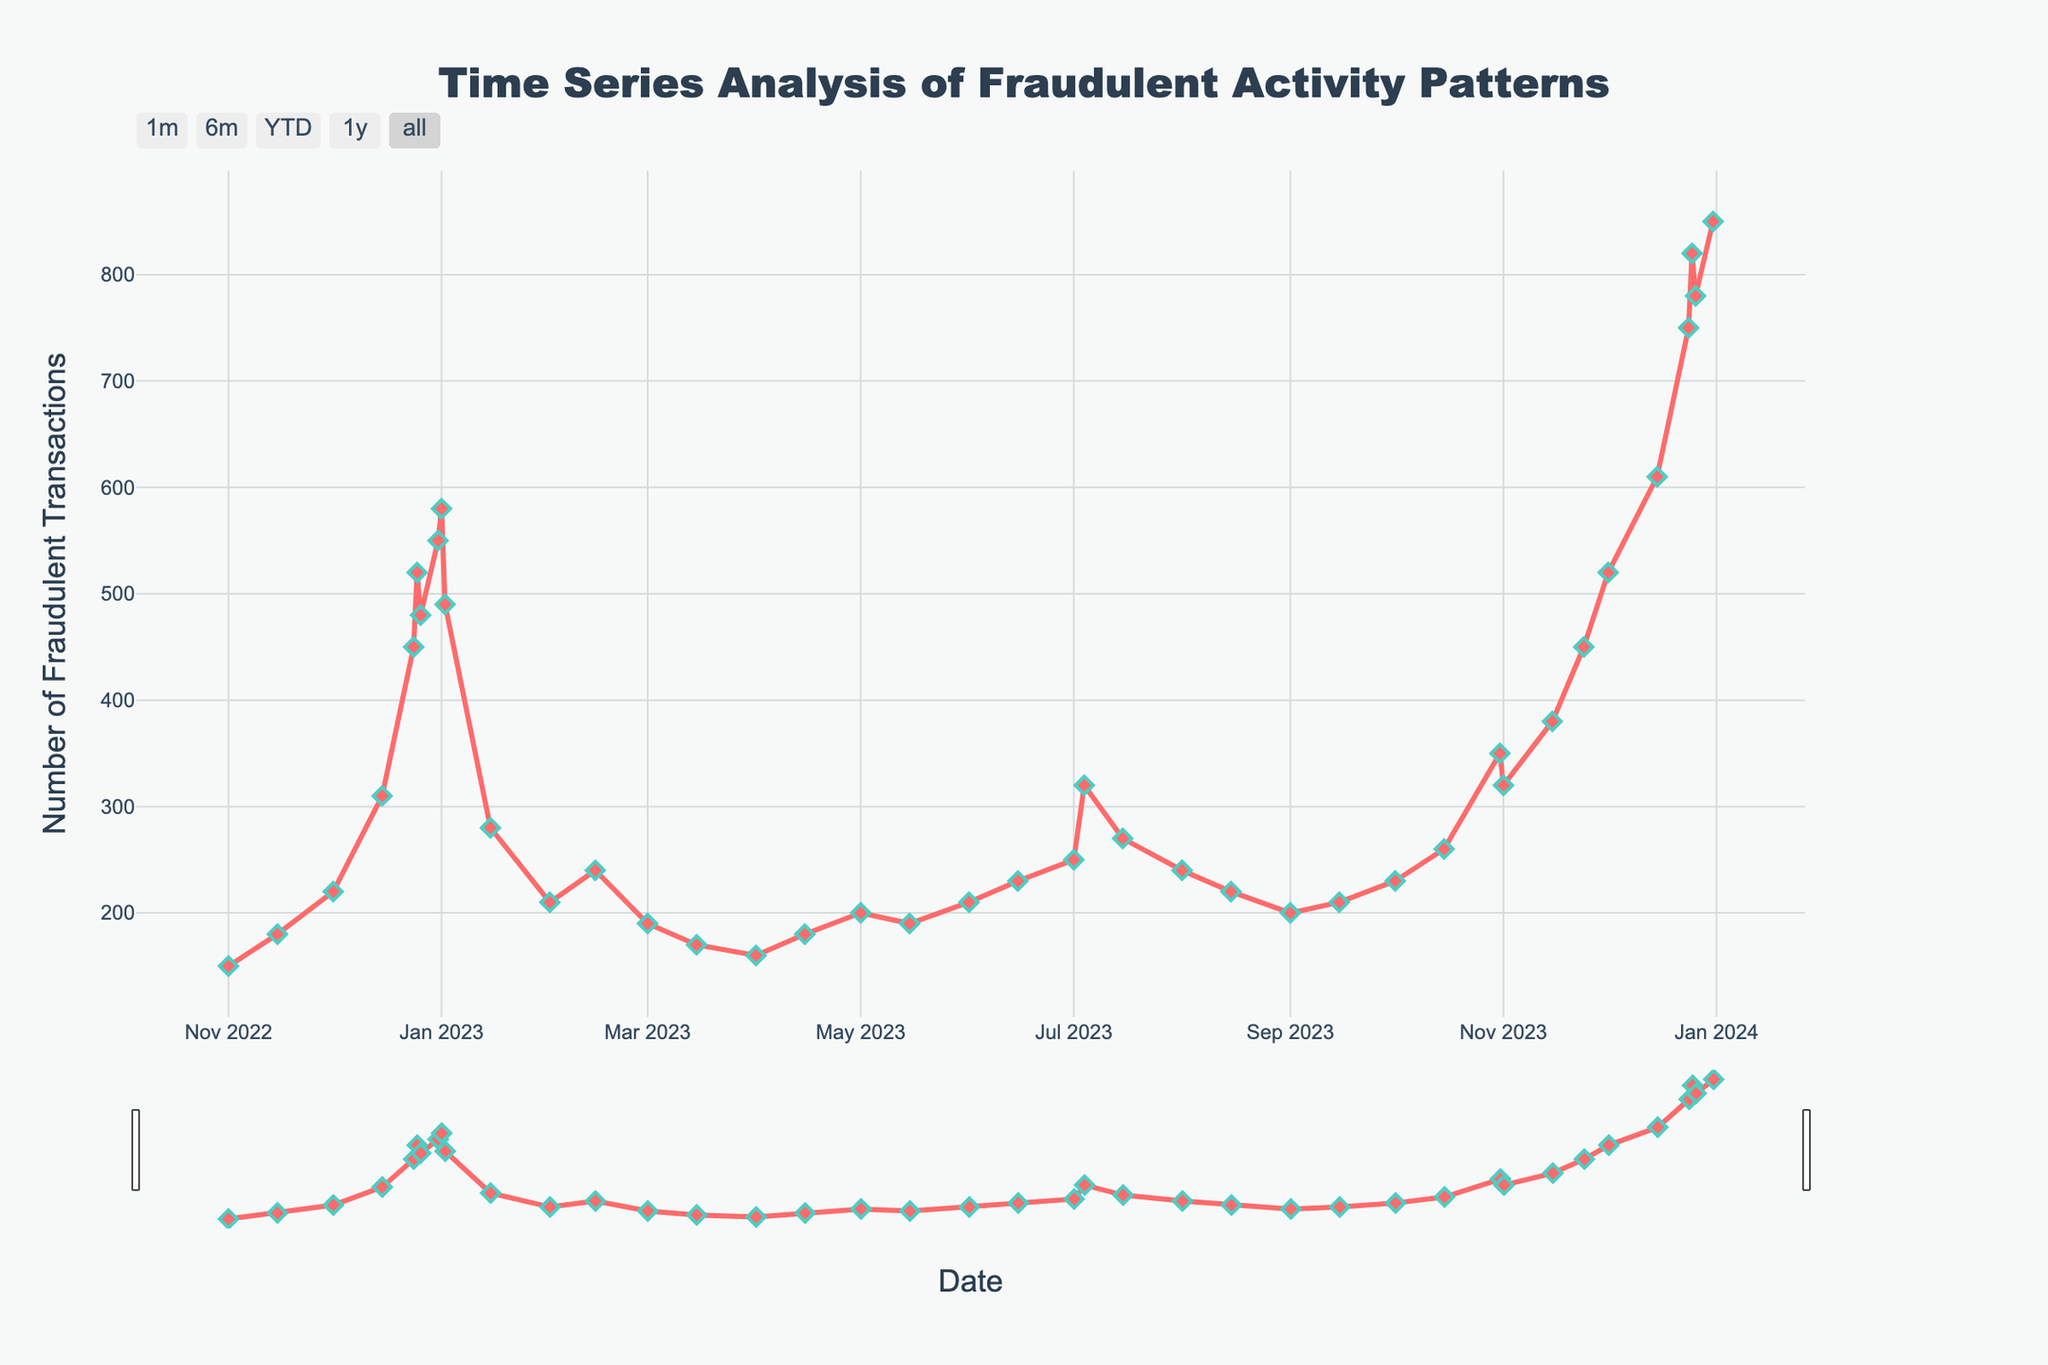What are the peak dates for fraudulent transactions? By examining the line chart, the peak dates for fraudulent transactions can be identified as dates where the data points are highest in the plot.
Answer: 2023-12-31 and 2023-12-25 How do the fraudulent transactions on December 25th compare to those on December 26th? In the chart, locate the data points corresponding to December 25th (820) and December 26th (780). Compare their values.
Answer: December 25th had more fraudulent transactions What is the average number of fraudulent transactions between December 24th to January 2nd in 2022-2023? Sum the data points from December 24th (450), December 25th (520), December 26th (480), December 31st (550), January 1st (580), and January 2nd (490). Then, divide by the number of dates (6). Average = (450+520+480+550+580+490) / 6 = 510
Answer: 510 What trend is observed in fraudulent transactions from November 24th to December 25th in 2023? Evaluate the increase or decrease in the data points from November 24th (450), December 1st (520), December 15th (610), December 24th (750), and December 25th (820).
Answer: Increasing trend How does the quantity of fraudulent transactions in December 2022 compare to December 2023? Compare the data points: 2022 - December 1st (220), December 15th (310), December 24th (450), December 25th (520), December 26th (480), December 31st (550); 2023 - December 1st (520), December 15th (610), December 24th (750), December 25th (820), December 26th (780), December 31st (850). Sum and compare them. 2022 total: 2530 2023 total: 4330
Answer: December 2023 had higher transactions What is the rate of change from January 1st, 2023 to January 2nd, 2023? Use the formula (Value on January 2nd - Value on January 1st) / Value on January 1st. (490 - 580) / 580 = -0.155
Answer: -15.5% On which holiday did the fraudulent transactions see the largest spike in 2023? Identify the largest increase between two consecutive data points around holidays such as December 24th to 25th (750 to 820).
Answer: December 25th How many data points show a steady number of fraudulent transactions (less than or equal to 10% change from the previous value)? Calculate the percentage change between consecutive data points. Identify how many changes are ≤ 10% by iterating through the dataset.
Answer: Several intermediate points such as February 1 and 14, April 1 and 15, etc Which period shows the most significant decrease in fraudulent transactions? Identify the largest drop by visually inspecting gaps where line descent is steepest, such as January 2nd (490) to January 15th (280).
Answer: Early January 2023 Is there any visual marker or special formatting used to highlight specific data points in the chart? Analyze the plot for special markers like diamonds, line colors, marker size, etc.
Answer: Red line with diamond markers 